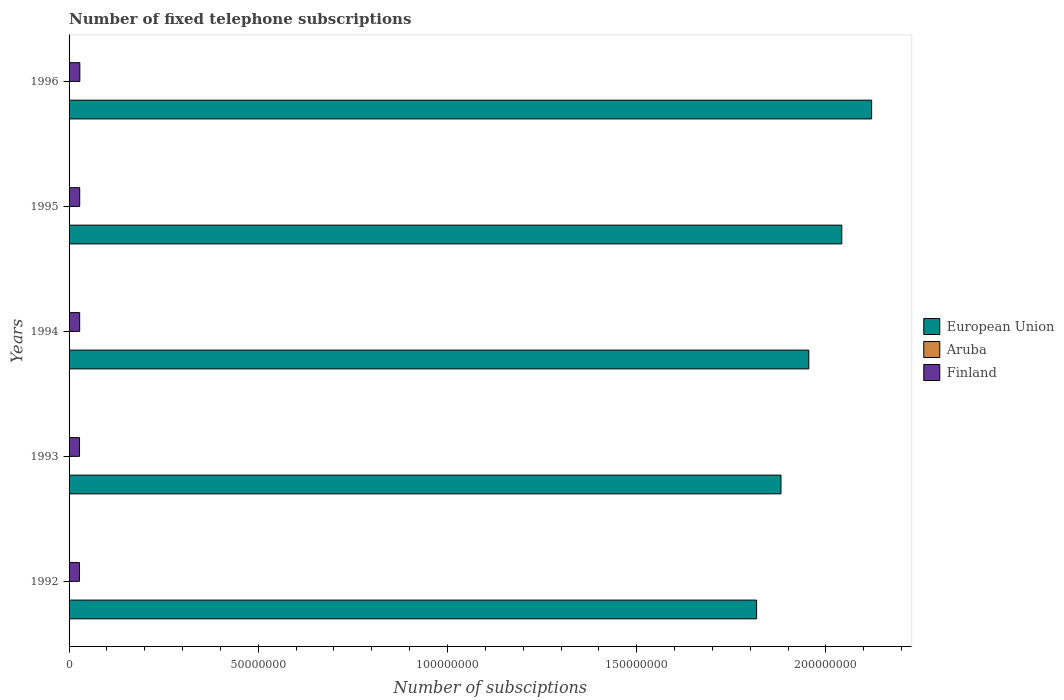How many bars are there on the 2nd tick from the top?
Your answer should be very brief. 3. What is the label of the 3rd group of bars from the top?
Give a very brief answer. 1994. In how many cases, is the number of bars for a given year not equal to the number of legend labels?
Make the answer very short. 0. What is the number of fixed telephone subscriptions in Finland in 1994?
Give a very brief answer. 2.80e+06. Across all years, what is the maximum number of fixed telephone subscriptions in Aruba?
Offer a very short reply. 3.36e+04. Across all years, what is the minimum number of fixed telephone subscriptions in Aruba?
Keep it short and to the point. 2.04e+04. In which year was the number of fixed telephone subscriptions in European Union maximum?
Ensure brevity in your answer.  1996. What is the total number of fixed telephone subscriptions in European Union in the graph?
Your response must be concise. 9.81e+08. What is the difference between the number of fixed telephone subscriptions in Finland in 1992 and that in 1993?
Offer a terse response. -2.11e+04. What is the difference between the number of fixed telephone subscriptions in Aruba in 1994 and the number of fixed telephone subscriptions in Finland in 1996?
Ensure brevity in your answer.  -2.82e+06. What is the average number of fixed telephone subscriptions in Aruba per year?
Ensure brevity in your answer.  2.48e+04. In the year 1996, what is the difference between the number of fixed telephone subscriptions in Finland and number of fixed telephone subscriptions in Aruba?
Make the answer very short. 2.81e+06. In how many years, is the number of fixed telephone subscriptions in Aruba greater than 40000000 ?
Keep it short and to the point. 0. What is the ratio of the number of fixed telephone subscriptions in Aruba in 1992 to that in 1996?
Provide a succinct answer. 0.61. Is the number of fixed telephone subscriptions in Aruba in 1995 less than that in 1996?
Your answer should be compact. Yes. What is the difference between the highest and the second highest number of fixed telephone subscriptions in Finland?
Your response must be concise. 3.20e+04. What is the difference between the highest and the lowest number of fixed telephone subscriptions in Finland?
Keep it short and to the point. 1.00e+05. In how many years, is the number of fixed telephone subscriptions in Aruba greater than the average number of fixed telephone subscriptions in Aruba taken over all years?
Provide a short and direct response. 2. Is the sum of the number of fixed telephone subscriptions in European Union in 1993 and 1994 greater than the maximum number of fixed telephone subscriptions in Finland across all years?
Keep it short and to the point. Yes. What does the 3rd bar from the top in 1994 represents?
Make the answer very short. European Union. Is it the case that in every year, the sum of the number of fixed telephone subscriptions in Aruba and number of fixed telephone subscriptions in European Union is greater than the number of fixed telephone subscriptions in Finland?
Your answer should be very brief. Yes. Are all the bars in the graph horizontal?
Make the answer very short. Yes. Are the values on the major ticks of X-axis written in scientific E-notation?
Provide a short and direct response. No. Does the graph contain any zero values?
Give a very brief answer. No. Does the graph contain grids?
Your answer should be very brief. No. How many legend labels are there?
Give a very brief answer. 3. What is the title of the graph?
Provide a short and direct response. Number of fixed telephone subscriptions. What is the label or title of the X-axis?
Ensure brevity in your answer.  Number of subsciptions. What is the label or title of the Y-axis?
Provide a succinct answer. Years. What is the Number of subsciptions of European Union in 1992?
Provide a succinct answer. 1.82e+08. What is the Number of subsciptions of Aruba in 1992?
Offer a terse response. 2.04e+04. What is the Number of subsciptions in Finland in 1992?
Your answer should be very brief. 2.74e+06. What is the Number of subsciptions of European Union in 1993?
Keep it short and to the point. 1.88e+08. What is the Number of subsciptions in Aruba in 1993?
Ensure brevity in your answer.  2.10e+04. What is the Number of subsciptions of Finland in 1993?
Your response must be concise. 2.76e+06. What is the Number of subsciptions in European Union in 1994?
Give a very brief answer. 1.95e+08. What is the Number of subsciptions in Aruba in 1994?
Make the answer very short. 2.15e+04. What is the Number of subsciptions in Finland in 1994?
Ensure brevity in your answer.  2.80e+06. What is the Number of subsciptions in European Union in 1995?
Your response must be concise. 2.04e+08. What is the Number of subsciptions in Aruba in 1995?
Your answer should be compact. 2.73e+04. What is the Number of subsciptions of Finland in 1995?
Give a very brief answer. 2.81e+06. What is the Number of subsciptions in European Union in 1996?
Offer a very short reply. 2.12e+08. What is the Number of subsciptions in Aruba in 1996?
Your answer should be very brief. 3.36e+04. What is the Number of subsciptions in Finland in 1996?
Provide a succinct answer. 2.84e+06. Across all years, what is the maximum Number of subsciptions in European Union?
Provide a succinct answer. 2.12e+08. Across all years, what is the maximum Number of subsciptions of Aruba?
Your answer should be very brief. 3.36e+04. Across all years, what is the maximum Number of subsciptions in Finland?
Provide a succinct answer. 2.84e+06. Across all years, what is the minimum Number of subsciptions in European Union?
Provide a succinct answer. 1.82e+08. Across all years, what is the minimum Number of subsciptions of Aruba?
Keep it short and to the point. 2.04e+04. Across all years, what is the minimum Number of subsciptions of Finland?
Offer a very short reply. 2.74e+06. What is the total Number of subsciptions in European Union in the graph?
Provide a succinct answer. 9.81e+08. What is the total Number of subsciptions of Aruba in the graph?
Ensure brevity in your answer.  1.24e+05. What is the total Number of subsciptions of Finland in the graph?
Your answer should be very brief. 1.40e+07. What is the difference between the Number of subsciptions of European Union in 1992 and that in 1993?
Provide a succinct answer. -6.44e+06. What is the difference between the Number of subsciptions in Aruba in 1992 and that in 1993?
Offer a terse response. -600. What is the difference between the Number of subsciptions of Finland in 1992 and that in 1993?
Ensure brevity in your answer.  -2.11e+04. What is the difference between the Number of subsciptions in European Union in 1992 and that in 1994?
Provide a succinct answer. -1.38e+07. What is the difference between the Number of subsciptions in Aruba in 1992 and that in 1994?
Your answer should be compact. -1100. What is the difference between the Number of subsciptions of Finland in 1992 and that in 1994?
Provide a short and direct response. -5.90e+04. What is the difference between the Number of subsciptions in European Union in 1992 and that in 1995?
Your answer should be compact. -2.25e+07. What is the difference between the Number of subsciptions of Aruba in 1992 and that in 1995?
Your response must be concise. -6900. What is the difference between the Number of subsciptions of Finland in 1992 and that in 1995?
Keep it short and to the point. -6.80e+04. What is the difference between the Number of subsciptions of European Union in 1992 and that in 1996?
Provide a short and direct response. -3.04e+07. What is the difference between the Number of subsciptions of Aruba in 1992 and that in 1996?
Give a very brief answer. -1.32e+04. What is the difference between the Number of subsciptions of Finland in 1992 and that in 1996?
Give a very brief answer. -1.00e+05. What is the difference between the Number of subsciptions in European Union in 1993 and that in 1994?
Provide a short and direct response. -7.35e+06. What is the difference between the Number of subsciptions of Aruba in 1993 and that in 1994?
Your answer should be compact. -500. What is the difference between the Number of subsciptions of Finland in 1993 and that in 1994?
Provide a succinct answer. -3.79e+04. What is the difference between the Number of subsciptions in European Union in 1993 and that in 1995?
Your response must be concise. -1.61e+07. What is the difference between the Number of subsciptions of Aruba in 1993 and that in 1995?
Provide a succinct answer. -6300. What is the difference between the Number of subsciptions in Finland in 1993 and that in 1995?
Provide a short and direct response. -4.69e+04. What is the difference between the Number of subsciptions of European Union in 1993 and that in 1996?
Provide a succinct answer. -2.40e+07. What is the difference between the Number of subsciptions in Aruba in 1993 and that in 1996?
Provide a succinct answer. -1.26e+04. What is the difference between the Number of subsciptions of Finland in 1993 and that in 1996?
Provide a succinct answer. -7.89e+04. What is the difference between the Number of subsciptions in European Union in 1994 and that in 1995?
Your answer should be compact. -8.71e+06. What is the difference between the Number of subsciptions in Aruba in 1994 and that in 1995?
Offer a very short reply. -5800. What is the difference between the Number of subsciptions of Finland in 1994 and that in 1995?
Make the answer very short. -9000. What is the difference between the Number of subsciptions of European Union in 1994 and that in 1996?
Your answer should be very brief. -1.66e+07. What is the difference between the Number of subsciptions in Aruba in 1994 and that in 1996?
Provide a succinct answer. -1.21e+04. What is the difference between the Number of subsciptions of Finland in 1994 and that in 1996?
Your response must be concise. -4.10e+04. What is the difference between the Number of subsciptions in European Union in 1995 and that in 1996?
Offer a very short reply. -7.89e+06. What is the difference between the Number of subsciptions of Aruba in 1995 and that in 1996?
Keep it short and to the point. -6276. What is the difference between the Number of subsciptions in Finland in 1995 and that in 1996?
Your answer should be very brief. -3.20e+04. What is the difference between the Number of subsciptions of European Union in 1992 and the Number of subsciptions of Aruba in 1993?
Offer a terse response. 1.82e+08. What is the difference between the Number of subsciptions of European Union in 1992 and the Number of subsciptions of Finland in 1993?
Ensure brevity in your answer.  1.79e+08. What is the difference between the Number of subsciptions in Aruba in 1992 and the Number of subsciptions in Finland in 1993?
Provide a succinct answer. -2.74e+06. What is the difference between the Number of subsciptions of European Union in 1992 and the Number of subsciptions of Aruba in 1994?
Offer a terse response. 1.82e+08. What is the difference between the Number of subsciptions in European Union in 1992 and the Number of subsciptions in Finland in 1994?
Your answer should be very brief. 1.79e+08. What is the difference between the Number of subsciptions of Aruba in 1992 and the Number of subsciptions of Finland in 1994?
Ensure brevity in your answer.  -2.78e+06. What is the difference between the Number of subsciptions of European Union in 1992 and the Number of subsciptions of Aruba in 1995?
Your response must be concise. 1.82e+08. What is the difference between the Number of subsciptions in European Union in 1992 and the Number of subsciptions in Finland in 1995?
Make the answer very short. 1.79e+08. What is the difference between the Number of subsciptions in Aruba in 1992 and the Number of subsciptions in Finland in 1995?
Your answer should be compact. -2.79e+06. What is the difference between the Number of subsciptions of European Union in 1992 and the Number of subsciptions of Aruba in 1996?
Offer a very short reply. 1.82e+08. What is the difference between the Number of subsciptions of European Union in 1992 and the Number of subsciptions of Finland in 1996?
Ensure brevity in your answer.  1.79e+08. What is the difference between the Number of subsciptions of Aruba in 1992 and the Number of subsciptions of Finland in 1996?
Give a very brief answer. -2.82e+06. What is the difference between the Number of subsciptions in European Union in 1993 and the Number of subsciptions in Aruba in 1994?
Your response must be concise. 1.88e+08. What is the difference between the Number of subsciptions of European Union in 1993 and the Number of subsciptions of Finland in 1994?
Your answer should be very brief. 1.85e+08. What is the difference between the Number of subsciptions of Aruba in 1993 and the Number of subsciptions of Finland in 1994?
Offer a very short reply. -2.78e+06. What is the difference between the Number of subsciptions of European Union in 1993 and the Number of subsciptions of Aruba in 1995?
Your response must be concise. 1.88e+08. What is the difference between the Number of subsciptions in European Union in 1993 and the Number of subsciptions in Finland in 1995?
Provide a succinct answer. 1.85e+08. What is the difference between the Number of subsciptions of Aruba in 1993 and the Number of subsciptions of Finland in 1995?
Your answer should be compact. -2.79e+06. What is the difference between the Number of subsciptions in European Union in 1993 and the Number of subsciptions in Aruba in 1996?
Give a very brief answer. 1.88e+08. What is the difference between the Number of subsciptions of European Union in 1993 and the Number of subsciptions of Finland in 1996?
Your answer should be very brief. 1.85e+08. What is the difference between the Number of subsciptions in Aruba in 1993 and the Number of subsciptions in Finland in 1996?
Give a very brief answer. -2.82e+06. What is the difference between the Number of subsciptions in European Union in 1994 and the Number of subsciptions in Aruba in 1995?
Your answer should be very brief. 1.95e+08. What is the difference between the Number of subsciptions in European Union in 1994 and the Number of subsciptions in Finland in 1995?
Provide a short and direct response. 1.93e+08. What is the difference between the Number of subsciptions in Aruba in 1994 and the Number of subsciptions in Finland in 1995?
Provide a short and direct response. -2.79e+06. What is the difference between the Number of subsciptions of European Union in 1994 and the Number of subsciptions of Aruba in 1996?
Keep it short and to the point. 1.95e+08. What is the difference between the Number of subsciptions of European Union in 1994 and the Number of subsciptions of Finland in 1996?
Make the answer very short. 1.93e+08. What is the difference between the Number of subsciptions of Aruba in 1994 and the Number of subsciptions of Finland in 1996?
Give a very brief answer. -2.82e+06. What is the difference between the Number of subsciptions in European Union in 1995 and the Number of subsciptions in Aruba in 1996?
Your answer should be very brief. 2.04e+08. What is the difference between the Number of subsciptions in European Union in 1995 and the Number of subsciptions in Finland in 1996?
Ensure brevity in your answer.  2.01e+08. What is the difference between the Number of subsciptions in Aruba in 1995 and the Number of subsciptions in Finland in 1996?
Keep it short and to the point. -2.81e+06. What is the average Number of subsciptions in European Union per year?
Your response must be concise. 1.96e+08. What is the average Number of subsciptions of Aruba per year?
Offer a terse response. 2.48e+04. What is the average Number of subsciptions in Finland per year?
Provide a succinct answer. 2.79e+06. In the year 1992, what is the difference between the Number of subsciptions in European Union and Number of subsciptions in Aruba?
Make the answer very short. 1.82e+08. In the year 1992, what is the difference between the Number of subsciptions of European Union and Number of subsciptions of Finland?
Your answer should be very brief. 1.79e+08. In the year 1992, what is the difference between the Number of subsciptions in Aruba and Number of subsciptions in Finland?
Offer a very short reply. -2.72e+06. In the year 1993, what is the difference between the Number of subsciptions of European Union and Number of subsciptions of Aruba?
Ensure brevity in your answer.  1.88e+08. In the year 1993, what is the difference between the Number of subsciptions of European Union and Number of subsciptions of Finland?
Ensure brevity in your answer.  1.85e+08. In the year 1993, what is the difference between the Number of subsciptions of Aruba and Number of subsciptions of Finland?
Provide a short and direct response. -2.74e+06. In the year 1994, what is the difference between the Number of subsciptions in European Union and Number of subsciptions in Aruba?
Provide a short and direct response. 1.95e+08. In the year 1994, what is the difference between the Number of subsciptions of European Union and Number of subsciptions of Finland?
Give a very brief answer. 1.93e+08. In the year 1994, what is the difference between the Number of subsciptions of Aruba and Number of subsciptions of Finland?
Keep it short and to the point. -2.78e+06. In the year 1995, what is the difference between the Number of subsciptions of European Union and Number of subsciptions of Aruba?
Your response must be concise. 2.04e+08. In the year 1995, what is the difference between the Number of subsciptions of European Union and Number of subsciptions of Finland?
Make the answer very short. 2.01e+08. In the year 1995, what is the difference between the Number of subsciptions of Aruba and Number of subsciptions of Finland?
Provide a short and direct response. -2.78e+06. In the year 1996, what is the difference between the Number of subsciptions of European Union and Number of subsciptions of Aruba?
Offer a terse response. 2.12e+08. In the year 1996, what is the difference between the Number of subsciptions of European Union and Number of subsciptions of Finland?
Ensure brevity in your answer.  2.09e+08. In the year 1996, what is the difference between the Number of subsciptions of Aruba and Number of subsciptions of Finland?
Offer a very short reply. -2.81e+06. What is the ratio of the Number of subsciptions of European Union in 1992 to that in 1993?
Your answer should be very brief. 0.97. What is the ratio of the Number of subsciptions in Aruba in 1992 to that in 1993?
Ensure brevity in your answer.  0.97. What is the ratio of the Number of subsciptions in Finland in 1992 to that in 1993?
Your answer should be compact. 0.99. What is the ratio of the Number of subsciptions of European Union in 1992 to that in 1994?
Your answer should be compact. 0.93. What is the ratio of the Number of subsciptions in Aruba in 1992 to that in 1994?
Offer a terse response. 0.95. What is the ratio of the Number of subsciptions in European Union in 1992 to that in 1995?
Offer a terse response. 0.89. What is the ratio of the Number of subsciptions in Aruba in 1992 to that in 1995?
Offer a terse response. 0.75. What is the ratio of the Number of subsciptions in Finland in 1992 to that in 1995?
Ensure brevity in your answer.  0.98. What is the ratio of the Number of subsciptions in European Union in 1992 to that in 1996?
Offer a terse response. 0.86. What is the ratio of the Number of subsciptions in Aruba in 1992 to that in 1996?
Your answer should be compact. 0.61. What is the ratio of the Number of subsciptions of Finland in 1992 to that in 1996?
Offer a very short reply. 0.96. What is the ratio of the Number of subsciptions of European Union in 1993 to that in 1994?
Make the answer very short. 0.96. What is the ratio of the Number of subsciptions of Aruba in 1993 to that in 1994?
Offer a terse response. 0.98. What is the ratio of the Number of subsciptions of Finland in 1993 to that in 1994?
Offer a very short reply. 0.99. What is the ratio of the Number of subsciptions of European Union in 1993 to that in 1995?
Provide a succinct answer. 0.92. What is the ratio of the Number of subsciptions of Aruba in 1993 to that in 1995?
Offer a terse response. 0.77. What is the ratio of the Number of subsciptions in Finland in 1993 to that in 1995?
Your answer should be compact. 0.98. What is the ratio of the Number of subsciptions of European Union in 1993 to that in 1996?
Provide a succinct answer. 0.89. What is the ratio of the Number of subsciptions in Aruba in 1993 to that in 1996?
Provide a short and direct response. 0.63. What is the ratio of the Number of subsciptions of Finland in 1993 to that in 1996?
Offer a very short reply. 0.97. What is the ratio of the Number of subsciptions in European Union in 1994 to that in 1995?
Give a very brief answer. 0.96. What is the ratio of the Number of subsciptions of Aruba in 1994 to that in 1995?
Offer a terse response. 0.79. What is the ratio of the Number of subsciptions in Finland in 1994 to that in 1995?
Give a very brief answer. 1. What is the ratio of the Number of subsciptions of European Union in 1994 to that in 1996?
Give a very brief answer. 0.92. What is the ratio of the Number of subsciptions in Aruba in 1994 to that in 1996?
Your answer should be very brief. 0.64. What is the ratio of the Number of subsciptions of Finland in 1994 to that in 1996?
Ensure brevity in your answer.  0.99. What is the ratio of the Number of subsciptions of European Union in 1995 to that in 1996?
Your answer should be compact. 0.96. What is the ratio of the Number of subsciptions in Aruba in 1995 to that in 1996?
Give a very brief answer. 0.81. What is the ratio of the Number of subsciptions of Finland in 1995 to that in 1996?
Ensure brevity in your answer.  0.99. What is the difference between the highest and the second highest Number of subsciptions in European Union?
Your answer should be very brief. 7.89e+06. What is the difference between the highest and the second highest Number of subsciptions in Aruba?
Keep it short and to the point. 6276. What is the difference between the highest and the second highest Number of subsciptions of Finland?
Give a very brief answer. 3.20e+04. What is the difference between the highest and the lowest Number of subsciptions of European Union?
Your answer should be very brief. 3.04e+07. What is the difference between the highest and the lowest Number of subsciptions of Aruba?
Give a very brief answer. 1.32e+04. What is the difference between the highest and the lowest Number of subsciptions in Finland?
Offer a very short reply. 1.00e+05. 